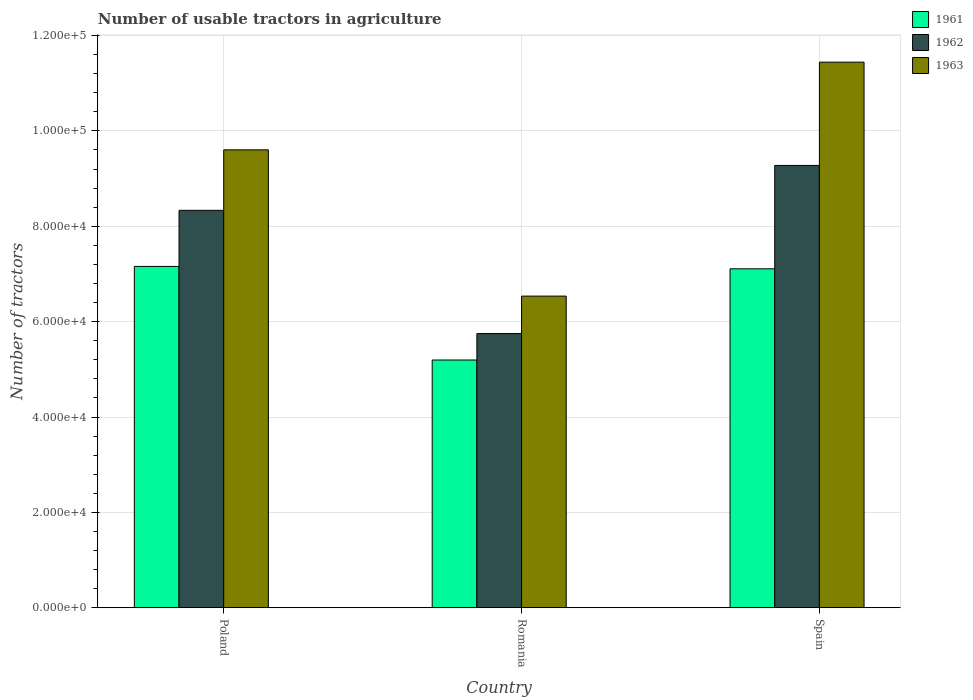Are the number of bars per tick equal to the number of legend labels?
Keep it short and to the point. Yes. Are the number of bars on each tick of the X-axis equal?
Your response must be concise. Yes. How many bars are there on the 2nd tick from the left?
Your response must be concise. 3. How many bars are there on the 1st tick from the right?
Ensure brevity in your answer.  3. What is the label of the 2nd group of bars from the left?
Make the answer very short. Romania. In how many cases, is the number of bars for a given country not equal to the number of legend labels?
Provide a short and direct response. 0. What is the number of usable tractors in agriculture in 1963 in Poland?
Offer a very short reply. 9.60e+04. Across all countries, what is the maximum number of usable tractors in agriculture in 1963?
Make the answer very short. 1.14e+05. Across all countries, what is the minimum number of usable tractors in agriculture in 1962?
Your response must be concise. 5.75e+04. In which country was the number of usable tractors in agriculture in 1963 minimum?
Provide a short and direct response. Romania. What is the total number of usable tractors in agriculture in 1963 in the graph?
Provide a succinct answer. 2.76e+05. What is the difference between the number of usable tractors in agriculture in 1962 in Poland and that in Romania?
Give a very brief answer. 2.58e+04. What is the difference between the number of usable tractors in agriculture in 1961 in Spain and the number of usable tractors in agriculture in 1963 in Romania?
Offer a terse response. 5726. What is the average number of usable tractors in agriculture in 1962 per country?
Make the answer very short. 7.79e+04. What is the difference between the number of usable tractors in agriculture of/in 1962 and number of usable tractors in agriculture of/in 1963 in Poland?
Your answer should be very brief. -1.27e+04. In how many countries, is the number of usable tractors in agriculture in 1962 greater than 48000?
Your answer should be very brief. 3. What is the ratio of the number of usable tractors in agriculture in 1963 in Romania to that in Spain?
Your answer should be compact. 0.57. Is the difference between the number of usable tractors in agriculture in 1962 in Romania and Spain greater than the difference between the number of usable tractors in agriculture in 1963 in Romania and Spain?
Make the answer very short. Yes. What is the difference between the highest and the second highest number of usable tractors in agriculture in 1963?
Offer a very short reply. 1.84e+04. What is the difference between the highest and the lowest number of usable tractors in agriculture in 1961?
Your response must be concise. 1.96e+04. What does the 1st bar from the right in Poland represents?
Make the answer very short. 1963. Is it the case that in every country, the sum of the number of usable tractors in agriculture in 1961 and number of usable tractors in agriculture in 1962 is greater than the number of usable tractors in agriculture in 1963?
Offer a very short reply. Yes. How many bars are there?
Offer a very short reply. 9. What is the difference between two consecutive major ticks on the Y-axis?
Keep it short and to the point. 2.00e+04. Are the values on the major ticks of Y-axis written in scientific E-notation?
Your response must be concise. Yes. Does the graph contain any zero values?
Make the answer very short. No. Where does the legend appear in the graph?
Ensure brevity in your answer.  Top right. What is the title of the graph?
Offer a terse response. Number of usable tractors in agriculture. Does "2012" appear as one of the legend labels in the graph?
Provide a succinct answer. No. What is the label or title of the Y-axis?
Your answer should be compact. Number of tractors. What is the Number of tractors in 1961 in Poland?
Provide a short and direct response. 7.16e+04. What is the Number of tractors of 1962 in Poland?
Your answer should be very brief. 8.33e+04. What is the Number of tractors of 1963 in Poland?
Provide a succinct answer. 9.60e+04. What is the Number of tractors of 1961 in Romania?
Offer a terse response. 5.20e+04. What is the Number of tractors in 1962 in Romania?
Offer a very short reply. 5.75e+04. What is the Number of tractors in 1963 in Romania?
Offer a very short reply. 6.54e+04. What is the Number of tractors of 1961 in Spain?
Provide a short and direct response. 7.11e+04. What is the Number of tractors of 1962 in Spain?
Keep it short and to the point. 9.28e+04. What is the Number of tractors in 1963 in Spain?
Offer a very short reply. 1.14e+05. Across all countries, what is the maximum Number of tractors of 1961?
Your answer should be very brief. 7.16e+04. Across all countries, what is the maximum Number of tractors in 1962?
Make the answer very short. 9.28e+04. Across all countries, what is the maximum Number of tractors in 1963?
Keep it short and to the point. 1.14e+05. Across all countries, what is the minimum Number of tractors in 1961?
Your answer should be compact. 5.20e+04. Across all countries, what is the minimum Number of tractors of 1962?
Your answer should be compact. 5.75e+04. Across all countries, what is the minimum Number of tractors in 1963?
Provide a succinct answer. 6.54e+04. What is the total Number of tractors of 1961 in the graph?
Offer a terse response. 1.95e+05. What is the total Number of tractors of 1962 in the graph?
Your response must be concise. 2.34e+05. What is the total Number of tractors in 1963 in the graph?
Offer a very short reply. 2.76e+05. What is the difference between the Number of tractors of 1961 in Poland and that in Romania?
Your answer should be compact. 1.96e+04. What is the difference between the Number of tractors in 1962 in Poland and that in Romania?
Offer a terse response. 2.58e+04. What is the difference between the Number of tractors of 1963 in Poland and that in Romania?
Ensure brevity in your answer.  3.07e+04. What is the difference between the Number of tractors in 1961 in Poland and that in Spain?
Ensure brevity in your answer.  500. What is the difference between the Number of tractors in 1962 in Poland and that in Spain?
Offer a terse response. -9414. What is the difference between the Number of tractors of 1963 in Poland and that in Spain?
Keep it short and to the point. -1.84e+04. What is the difference between the Number of tractors in 1961 in Romania and that in Spain?
Ensure brevity in your answer.  -1.91e+04. What is the difference between the Number of tractors in 1962 in Romania and that in Spain?
Provide a succinct answer. -3.53e+04. What is the difference between the Number of tractors of 1963 in Romania and that in Spain?
Your answer should be compact. -4.91e+04. What is the difference between the Number of tractors in 1961 in Poland and the Number of tractors in 1962 in Romania?
Provide a short and direct response. 1.41e+04. What is the difference between the Number of tractors in 1961 in Poland and the Number of tractors in 1963 in Romania?
Make the answer very short. 6226. What is the difference between the Number of tractors in 1962 in Poland and the Number of tractors in 1963 in Romania?
Keep it short and to the point. 1.80e+04. What is the difference between the Number of tractors in 1961 in Poland and the Number of tractors in 1962 in Spain?
Your answer should be very brief. -2.12e+04. What is the difference between the Number of tractors in 1961 in Poland and the Number of tractors in 1963 in Spain?
Keep it short and to the point. -4.28e+04. What is the difference between the Number of tractors of 1962 in Poland and the Number of tractors of 1963 in Spain?
Keep it short and to the point. -3.11e+04. What is the difference between the Number of tractors of 1961 in Romania and the Number of tractors of 1962 in Spain?
Offer a terse response. -4.08e+04. What is the difference between the Number of tractors in 1961 in Romania and the Number of tractors in 1963 in Spain?
Provide a succinct answer. -6.25e+04. What is the difference between the Number of tractors of 1962 in Romania and the Number of tractors of 1963 in Spain?
Offer a terse response. -5.69e+04. What is the average Number of tractors of 1961 per country?
Provide a succinct answer. 6.49e+04. What is the average Number of tractors of 1962 per country?
Provide a succinct answer. 7.79e+04. What is the average Number of tractors of 1963 per country?
Keep it short and to the point. 9.19e+04. What is the difference between the Number of tractors in 1961 and Number of tractors in 1962 in Poland?
Your answer should be very brief. -1.18e+04. What is the difference between the Number of tractors in 1961 and Number of tractors in 1963 in Poland?
Keep it short and to the point. -2.44e+04. What is the difference between the Number of tractors of 1962 and Number of tractors of 1963 in Poland?
Provide a succinct answer. -1.27e+04. What is the difference between the Number of tractors of 1961 and Number of tractors of 1962 in Romania?
Keep it short and to the point. -5548. What is the difference between the Number of tractors in 1961 and Number of tractors in 1963 in Romania?
Your answer should be very brief. -1.34e+04. What is the difference between the Number of tractors in 1962 and Number of tractors in 1963 in Romania?
Ensure brevity in your answer.  -7851. What is the difference between the Number of tractors of 1961 and Number of tractors of 1962 in Spain?
Your response must be concise. -2.17e+04. What is the difference between the Number of tractors in 1961 and Number of tractors in 1963 in Spain?
Your answer should be compact. -4.33e+04. What is the difference between the Number of tractors of 1962 and Number of tractors of 1963 in Spain?
Offer a very short reply. -2.17e+04. What is the ratio of the Number of tractors in 1961 in Poland to that in Romania?
Your response must be concise. 1.38. What is the ratio of the Number of tractors of 1962 in Poland to that in Romania?
Your answer should be compact. 1.45. What is the ratio of the Number of tractors in 1963 in Poland to that in Romania?
Ensure brevity in your answer.  1.47. What is the ratio of the Number of tractors of 1962 in Poland to that in Spain?
Your response must be concise. 0.9. What is the ratio of the Number of tractors in 1963 in Poland to that in Spain?
Make the answer very short. 0.84. What is the ratio of the Number of tractors of 1961 in Romania to that in Spain?
Provide a short and direct response. 0.73. What is the ratio of the Number of tractors in 1962 in Romania to that in Spain?
Provide a short and direct response. 0.62. What is the ratio of the Number of tractors of 1963 in Romania to that in Spain?
Make the answer very short. 0.57. What is the difference between the highest and the second highest Number of tractors in 1962?
Provide a succinct answer. 9414. What is the difference between the highest and the second highest Number of tractors in 1963?
Your answer should be very brief. 1.84e+04. What is the difference between the highest and the lowest Number of tractors in 1961?
Your response must be concise. 1.96e+04. What is the difference between the highest and the lowest Number of tractors in 1962?
Give a very brief answer. 3.53e+04. What is the difference between the highest and the lowest Number of tractors in 1963?
Give a very brief answer. 4.91e+04. 